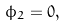<formula> <loc_0><loc_0><loc_500><loc_500>\phi _ { 2 } = 0 ,</formula> 